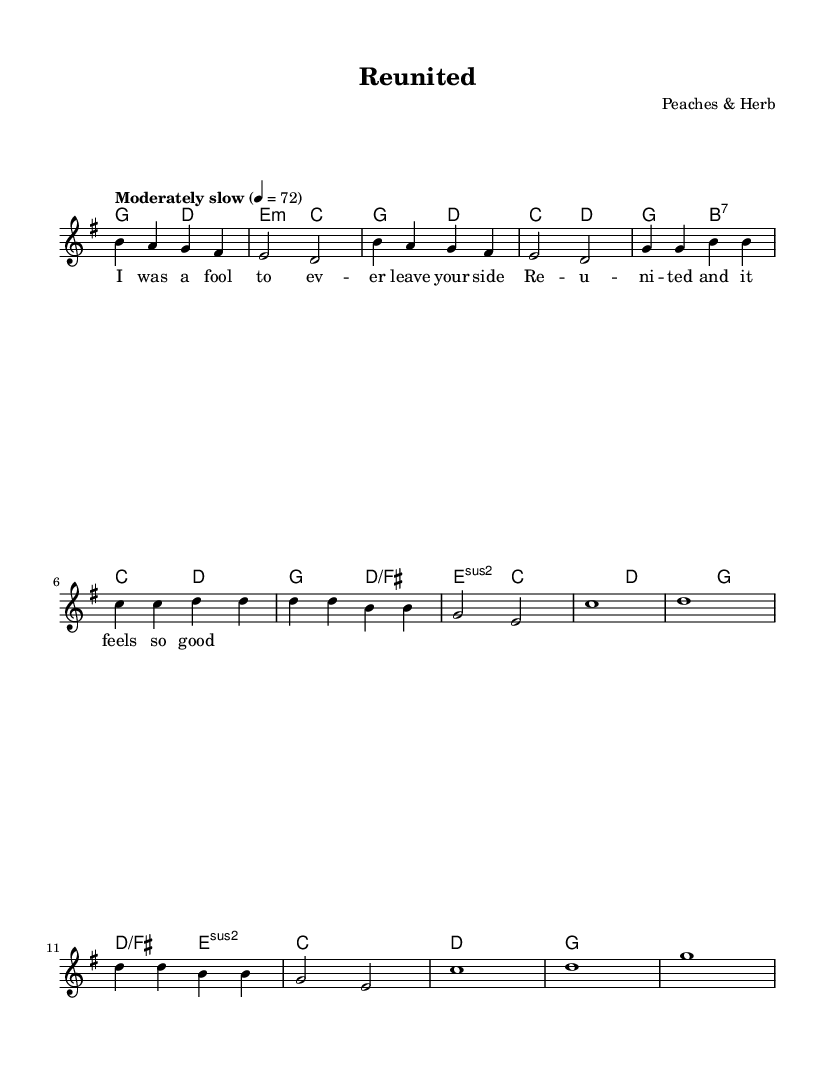What is the key signature of this music? The key signature indicates G major as there is one sharp (F#).
Answer: G major What is the time signature of the piece? The time signature is recorded as 4/4, indicating four beats per measure.
Answer: 4/4 What is the tempo marking for this piece? The tempo marking indicates "Moderately slow" at a metronome marking of 72 beats per minute.
Answer: Moderately slow How many measures are in the verse section? In the melody section labeled "Verse", there are 6 measures. This can be counted on the sheet music.
Answer: 6 How many total unique chords are used in the harmonies section? Upon analyzing the chord symbols, there are 6 unique chords used: G, D, E minor, C, B7, and D/F#.
Answer: 6 Which artist composed "Reunited"? The header information clearly states that "Reunited" was composed by Peaches & Herb.
Answer: Peaches & Herb What section follows the verse in the structure of the song? The song structure indicates that after the verse, the chorus section follows.
Answer: Chorus 